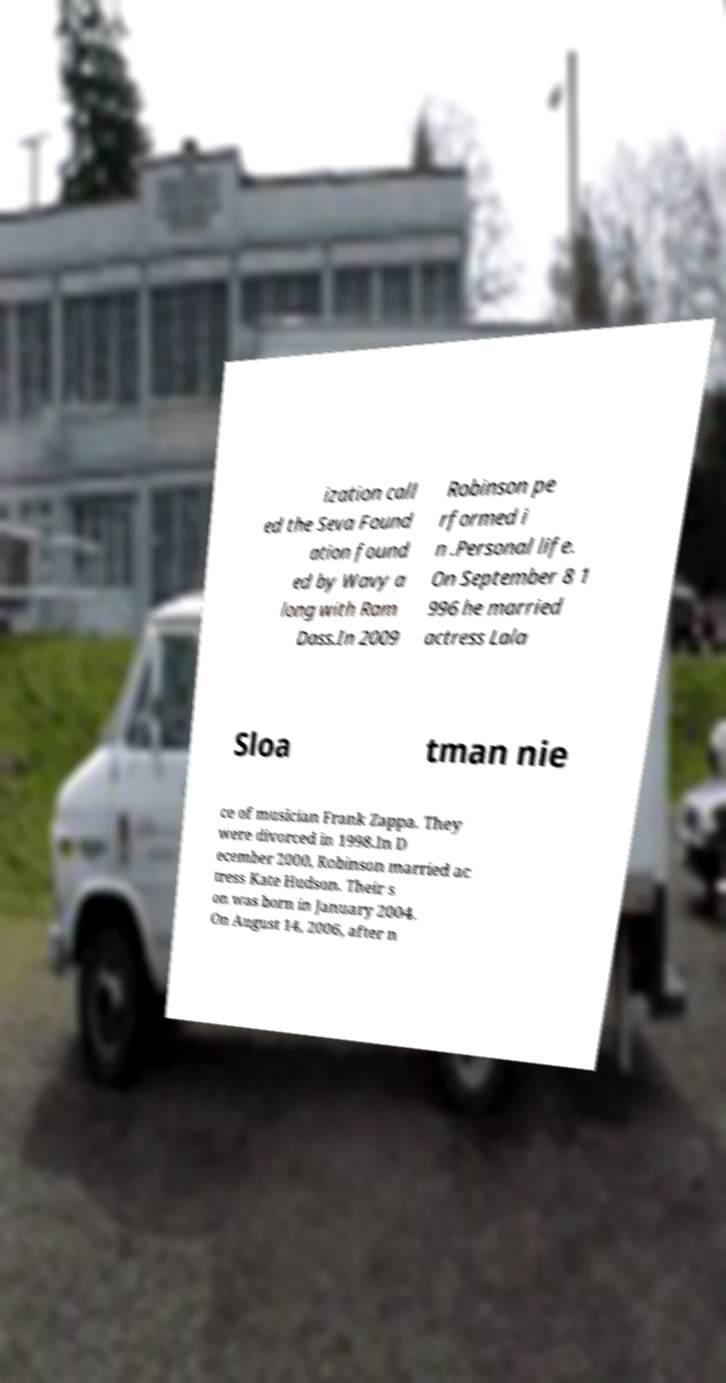Please read and relay the text visible in this image. What does it say? ization call ed the Seva Found ation found ed by Wavy a long with Ram Dass.In 2009 Robinson pe rformed i n .Personal life. On September 8 1 996 he married actress Lala Sloa tman nie ce of musician Frank Zappa. They were divorced in 1998.In D ecember 2000, Robinson married ac tress Kate Hudson. Their s on was born in January 2004. On August 14, 2006, after n 